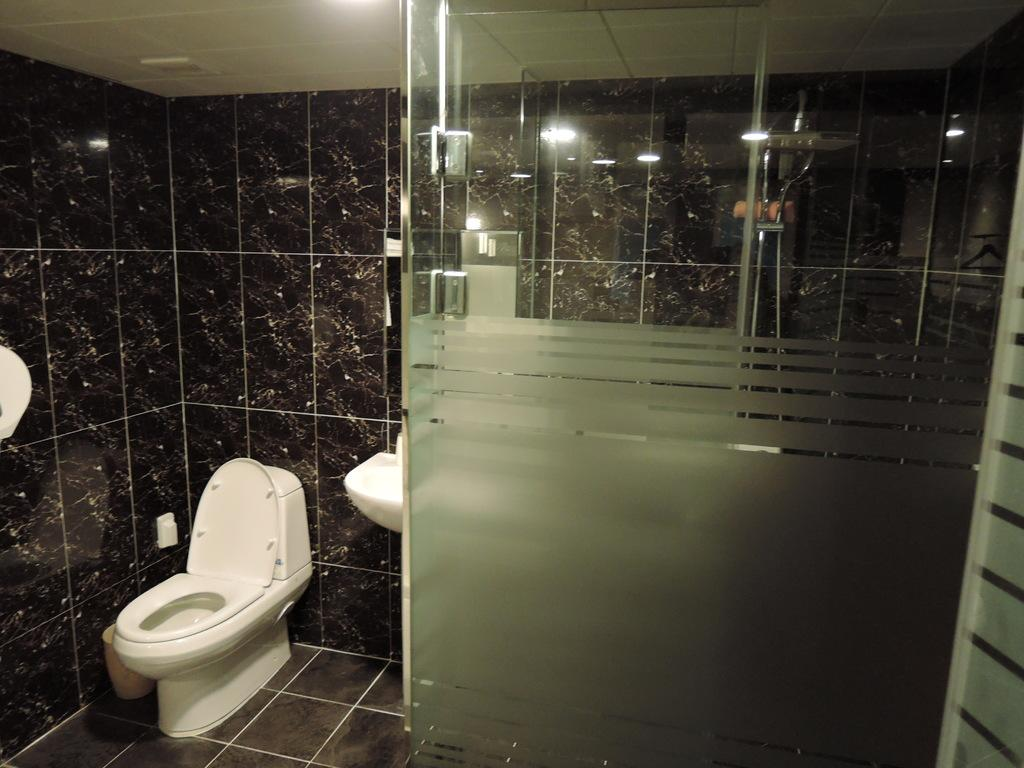What is placed on the floor in the image? There is a toilet seat on the floor in the image. What can be seen in the background of the image? There are lights, a roof, and additional objects in the background of the image. What is the purpose of the sink in the image? The sink is likely used for washing hands or other cleaning purposes. What type of objects are visible in the image? There are some objects visible in the image, but their specific nature is not mentioned in the facts. What type of humor can be seen in the cave in the image? There is no cave present in the image, so it is not possible to determine if any humor can be seen in a cave. 